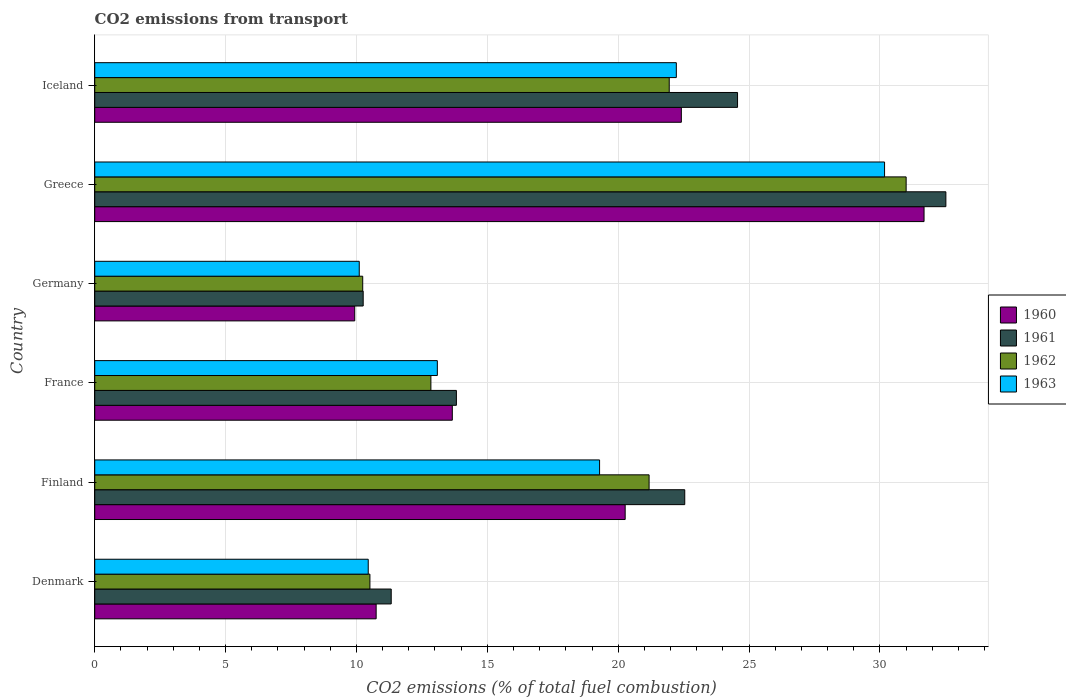How many groups of bars are there?
Your response must be concise. 6. Are the number of bars per tick equal to the number of legend labels?
Ensure brevity in your answer.  Yes. How many bars are there on the 3rd tick from the top?
Offer a very short reply. 4. How many bars are there on the 6th tick from the bottom?
Offer a terse response. 4. What is the label of the 4th group of bars from the top?
Your answer should be very brief. France. What is the total CO2 emitted in 1960 in Denmark?
Keep it short and to the point. 10.75. Across all countries, what is the maximum total CO2 emitted in 1963?
Your answer should be compact. 30.18. Across all countries, what is the minimum total CO2 emitted in 1961?
Your response must be concise. 10.26. In which country was the total CO2 emitted in 1960 minimum?
Your answer should be compact. Germany. What is the total total CO2 emitted in 1963 in the graph?
Provide a succinct answer. 105.34. What is the difference between the total CO2 emitted in 1961 in France and that in Greece?
Provide a short and direct response. -18.7. What is the difference between the total CO2 emitted in 1961 in Denmark and the total CO2 emitted in 1962 in Finland?
Provide a short and direct response. -9.85. What is the average total CO2 emitted in 1962 per country?
Your answer should be very brief. 17.96. What is the difference between the total CO2 emitted in 1961 and total CO2 emitted in 1960 in Germany?
Offer a very short reply. 0.32. What is the ratio of the total CO2 emitted in 1962 in France to that in Iceland?
Provide a short and direct response. 0.59. Is the difference between the total CO2 emitted in 1961 in Denmark and Iceland greater than the difference between the total CO2 emitted in 1960 in Denmark and Iceland?
Your answer should be very brief. No. What is the difference between the highest and the second highest total CO2 emitted in 1960?
Make the answer very short. 9.27. What is the difference between the highest and the lowest total CO2 emitted in 1961?
Offer a terse response. 22.26. In how many countries, is the total CO2 emitted in 1960 greater than the average total CO2 emitted in 1960 taken over all countries?
Your answer should be very brief. 3. Is the sum of the total CO2 emitted in 1963 in Denmark and Iceland greater than the maximum total CO2 emitted in 1961 across all countries?
Your response must be concise. Yes. Is it the case that in every country, the sum of the total CO2 emitted in 1961 and total CO2 emitted in 1960 is greater than the sum of total CO2 emitted in 1962 and total CO2 emitted in 1963?
Ensure brevity in your answer.  No. What does the 1st bar from the top in Denmark represents?
Keep it short and to the point. 1963. Is it the case that in every country, the sum of the total CO2 emitted in 1960 and total CO2 emitted in 1963 is greater than the total CO2 emitted in 1961?
Give a very brief answer. Yes. Are the values on the major ticks of X-axis written in scientific E-notation?
Give a very brief answer. No. Does the graph contain any zero values?
Offer a terse response. No. How are the legend labels stacked?
Make the answer very short. Vertical. What is the title of the graph?
Your response must be concise. CO2 emissions from transport. What is the label or title of the X-axis?
Your answer should be compact. CO2 emissions (% of total fuel combustion). What is the CO2 emissions (% of total fuel combustion) of 1960 in Denmark?
Keep it short and to the point. 10.75. What is the CO2 emissions (% of total fuel combustion) in 1961 in Denmark?
Offer a terse response. 11.33. What is the CO2 emissions (% of total fuel combustion) in 1962 in Denmark?
Make the answer very short. 10.51. What is the CO2 emissions (% of total fuel combustion) of 1963 in Denmark?
Your response must be concise. 10.45. What is the CO2 emissions (% of total fuel combustion) in 1960 in Finland?
Provide a succinct answer. 20.27. What is the CO2 emissions (% of total fuel combustion) of 1961 in Finland?
Your response must be concise. 22.54. What is the CO2 emissions (% of total fuel combustion) of 1962 in Finland?
Provide a short and direct response. 21.18. What is the CO2 emissions (% of total fuel combustion) in 1963 in Finland?
Ensure brevity in your answer.  19.29. What is the CO2 emissions (% of total fuel combustion) in 1960 in France?
Give a very brief answer. 13.66. What is the CO2 emissions (% of total fuel combustion) in 1961 in France?
Offer a very short reply. 13.82. What is the CO2 emissions (% of total fuel combustion) of 1962 in France?
Provide a short and direct response. 12.84. What is the CO2 emissions (% of total fuel combustion) in 1963 in France?
Ensure brevity in your answer.  13.09. What is the CO2 emissions (% of total fuel combustion) of 1960 in Germany?
Make the answer very short. 9.93. What is the CO2 emissions (% of total fuel combustion) of 1961 in Germany?
Your response must be concise. 10.26. What is the CO2 emissions (% of total fuel combustion) in 1962 in Germany?
Give a very brief answer. 10.24. What is the CO2 emissions (% of total fuel combustion) in 1963 in Germany?
Keep it short and to the point. 10.11. What is the CO2 emissions (% of total fuel combustion) of 1960 in Greece?
Your answer should be very brief. 31.69. What is the CO2 emissions (% of total fuel combustion) in 1961 in Greece?
Offer a terse response. 32.52. What is the CO2 emissions (% of total fuel combustion) of 1962 in Greece?
Provide a short and direct response. 31. What is the CO2 emissions (% of total fuel combustion) of 1963 in Greece?
Provide a short and direct response. 30.18. What is the CO2 emissions (% of total fuel combustion) of 1960 in Iceland?
Keep it short and to the point. 22.41. What is the CO2 emissions (% of total fuel combustion) in 1961 in Iceland?
Give a very brief answer. 24.56. What is the CO2 emissions (% of total fuel combustion) of 1962 in Iceland?
Offer a terse response. 21.95. What is the CO2 emissions (% of total fuel combustion) in 1963 in Iceland?
Offer a terse response. 22.22. Across all countries, what is the maximum CO2 emissions (% of total fuel combustion) in 1960?
Give a very brief answer. 31.69. Across all countries, what is the maximum CO2 emissions (% of total fuel combustion) of 1961?
Ensure brevity in your answer.  32.52. Across all countries, what is the maximum CO2 emissions (% of total fuel combustion) of 1962?
Keep it short and to the point. 31. Across all countries, what is the maximum CO2 emissions (% of total fuel combustion) in 1963?
Your answer should be compact. 30.18. Across all countries, what is the minimum CO2 emissions (% of total fuel combustion) in 1960?
Ensure brevity in your answer.  9.93. Across all countries, what is the minimum CO2 emissions (% of total fuel combustion) in 1961?
Ensure brevity in your answer.  10.26. Across all countries, what is the minimum CO2 emissions (% of total fuel combustion) of 1962?
Offer a terse response. 10.24. Across all countries, what is the minimum CO2 emissions (% of total fuel combustion) of 1963?
Your answer should be very brief. 10.11. What is the total CO2 emissions (% of total fuel combustion) in 1960 in the graph?
Your answer should be very brief. 108.72. What is the total CO2 emissions (% of total fuel combustion) in 1961 in the graph?
Your answer should be very brief. 115.03. What is the total CO2 emissions (% of total fuel combustion) of 1962 in the graph?
Your answer should be compact. 107.73. What is the total CO2 emissions (% of total fuel combustion) in 1963 in the graph?
Offer a terse response. 105.34. What is the difference between the CO2 emissions (% of total fuel combustion) of 1960 in Denmark and that in Finland?
Make the answer very short. -9.51. What is the difference between the CO2 emissions (% of total fuel combustion) of 1961 in Denmark and that in Finland?
Ensure brevity in your answer.  -11.22. What is the difference between the CO2 emissions (% of total fuel combustion) in 1962 in Denmark and that in Finland?
Ensure brevity in your answer.  -10.67. What is the difference between the CO2 emissions (% of total fuel combustion) in 1963 in Denmark and that in Finland?
Keep it short and to the point. -8.84. What is the difference between the CO2 emissions (% of total fuel combustion) in 1960 in Denmark and that in France?
Give a very brief answer. -2.91. What is the difference between the CO2 emissions (% of total fuel combustion) of 1961 in Denmark and that in France?
Ensure brevity in your answer.  -2.49. What is the difference between the CO2 emissions (% of total fuel combustion) of 1962 in Denmark and that in France?
Give a very brief answer. -2.33. What is the difference between the CO2 emissions (% of total fuel combustion) of 1963 in Denmark and that in France?
Offer a very short reply. -2.64. What is the difference between the CO2 emissions (% of total fuel combustion) in 1960 in Denmark and that in Germany?
Your answer should be very brief. 0.82. What is the difference between the CO2 emissions (% of total fuel combustion) of 1961 in Denmark and that in Germany?
Your answer should be very brief. 1.07. What is the difference between the CO2 emissions (% of total fuel combustion) of 1962 in Denmark and that in Germany?
Provide a short and direct response. 0.28. What is the difference between the CO2 emissions (% of total fuel combustion) of 1963 in Denmark and that in Germany?
Your answer should be very brief. 0.34. What is the difference between the CO2 emissions (% of total fuel combustion) in 1960 in Denmark and that in Greece?
Keep it short and to the point. -20.93. What is the difference between the CO2 emissions (% of total fuel combustion) in 1961 in Denmark and that in Greece?
Make the answer very short. -21.19. What is the difference between the CO2 emissions (% of total fuel combustion) of 1962 in Denmark and that in Greece?
Make the answer very short. -20.49. What is the difference between the CO2 emissions (% of total fuel combustion) in 1963 in Denmark and that in Greece?
Keep it short and to the point. -19.73. What is the difference between the CO2 emissions (% of total fuel combustion) of 1960 in Denmark and that in Iceland?
Make the answer very short. -11.66. What is the difference between the CO2 emissions (% of total fuel combustion) in 1961 in Denmark and that in Iceland?
Give a very brief answer. -13.23. What is the difference between the CO2 emissions (% of total fuel combustion) of 1962 in Denmark and that in Iceland?
Offer a very short reply. -11.44. What is the difference between the CO2 emissions (% of total fuel combustion) of 1963 in Denmark and that in Iceland?
Provide a succinct answer. -11.77. What is the difference between the CO2 emissions (% of total fuel combustion) in 1960 in Finland and that in France?
Offer a very short reply. 6.6. What is the difference between the CO2 emissions (% of total fuel combustion) in 1961 in Finland and that in France?
Offer a terse response. 8.73. What is the difference between the CO2 emissions (% of total fuel combustion) in 1962 in Finland and that in France?
Offer a terse response. 8.34. What is the difference between the CO2 emissions (% of total fuel combustion) in 1963 in Finland and that in France?
Your answer should be compact. 6.2. What is the difference between the CO2 emissions (% of total fuel combustion) in 1960 in Finland and that in Germany?
Provide a short and direct response. 10.33. What is the difference between the CO2 emissions (% of total fuel combustion) of 1961 in Finland and that in Germany?
Offer a terse response. 12.29. What is the difference between the CO2 emissions (% of total fuel combustion) in 1962 in Finland and that in Germany?
Your answer should be very brief. 10.94. What is the difference between the CO2 emissions (% of total fuel combustion) of 1963 in Finland and that in Germany?
Your answer should be compact. 9.18. What is the difference between the CO2 emissions (% of total fuel combustion) of 1960 in Finland and that in Greece?
Ensure brevity in your answer.  -11.42. What is the difference between the CO2 emissions (% of total fuel combustion) in 1961 in Finland and that in Greece?
Ensure brevity in your answer.  -9.98. What is the difference between the CO2 emissions (% of total fuel combustion) of 1962 in Finland and that in Greece?
Offer a very short reply. -9.82. What is the difference between the CO2 emissions (% of total fuel combustion) in 1963 in Finland and that in Greece?
Provide a short and direct response. -10.89. What is the difference between the CO2 emissions (% of total fuel combustion) in 1960 in Finland and that in Iceland?
Your answer should be very brief. -2.15. What is the difference between the CO2 emissions (% of total fuel combustion) in 1961 in Finland and that in Iceland?
Your answer should be compact. -2.02. What is the difference between the CO2 emissions (% of total fuel combustion) of 1962 in Finland and that in Iceland?
Make the answer very short. -0.77. What is the difference between the CO2 emissions (% of total fuel combustion) of 1963 in Finland and that in Iceland?
Your answer should be very brief. -2.93. What is the difference between the CO2 emissions (% of total fuel combustion) in 1960 in France and that in Germany?
Your answer should be very brief. 3.73. What is the difference between the CO2 emissions (% of total fuel combustion) of 1961 in France and that in Germany?
Provide a short and direct response. 3.56. What is the difference between the CO2 emissions (% of total fuel combustion) in 1962 in France and that in Germany?
Your answer should be compact. 2.6. What is the difference between the CO2 emissions (% of total fuel combustion) of 1963 in France and that in Germany?
Offer a very short reply. 2.98. What is the difference between the CO2 emissions (% of total fuel combustion) of 1960 in France and that in Greece?
Offer a terse response. -18.02. What is the difference between the CO2 emissions (% of total fuel combustion) in 1961 in France and that in Greece?
Provide a succinct answer. -18.7. What is the difference between the CO2 emissions (% of total fuel combustion) in 1962 in France and that in Greece?
Your answer should be very brief. -18.16. What is the difference between the CO2 emissions (% of total fuel combustion) of 1963 in France and that in Greece?
Your response must be concise. -17.09. What is the difference between the CO2 emissions (% of total fuel combustion) in 1960 in France and that in Iceland?
Your answer should be compact. -8.75. What is the difference between the CO2 emissions (% of total fuel combustion) in 1961 in France and that in Iceland?
Offer a terse response. -10.74. What is the difference between the CO2 emissions (% of total fuel combustion) of 1962 in France and that in Iceland?
Your response must be concise. -9.11. What is the difference between the CO2 emissions (% of total fuel combustion) of 1963 in France and that in Iceland?
Offer a terse response. -9.13. What is the difference between the CO2 emissions (% of total fuel combustion) in 1960 in Germany and that in Greece?
Provide a short and direct response. -21.75. What is the difference between the CO2 emissions (% of total fuel combustion) of 1961 in Germany and that in Greece?
Make the answer very short. -22.26. What is the difference between the CO2 emissions (% of total fuel combustion) of 1962 in Germany and that in Greece?
Provide a short and direct response. -20.76. What is the difference between the CO2 emissions (% of total fuel combustion) in 1963 in Germany and that in Greece?
Offer a very short reply. -20.07. What is the difference between the CO2 emissions (% of total fuel combustion) of 1960 in Germany and that in Iceland?
Keep it short and to the point. -12.48. What is the difference between the CO2 emissions (% of total fuel combustion) in 1961 in Germany and that in Iceland?
Keep it short and to the point. -14.3. What is the difference between the CO2 emissions (% of total fuel combustion) of 1962 in Germany and that in Iceland?
Your response must be concise. -11.71. What is the difference between the CO2 emissions (% of total fuel combustion) of 1963 in Germany and that in Iceland?
Keep it short and to the point. -12.12. What is the difference between the CO2 emissions (% of total fuel combustion) in 1960 in Greece and that in Iceland?
Your answer should be very brief. 9.27. What is the difference between the CO2 emissions (% of total fuel combustion) in 1961 in Greece and that in Iceland?
Your response must be concise. 7.96. What is the difference between the CO2 emissions (% of total fuel combustion) in 1962 in Greece and that in Iceland?
Provide a short and direct response. 9.05. What is the difference between the CO2 emissions (% of total fuel combustion) of 1963 in Greece and that in Iceland?
Your response must be concise. 7.96. What is the difference between the CO2 emissions (% of total fuel combustion) in 1960 in Denmark and the CO2 emissions (% of total fuel combustion) in 1961 in Finland?
Ensure brevity in your answer.  -11.79. What is the difference between the CO2 emissions (% of total fuel combustion) in 1960 in Denmark and the CO2 emissions (% of total fuel combustion) in 1962 in Finland?
Ensure brevity in your answer.  -10.43. What is the difference between the CO2 emissions (% of total fuel combustion) in 1960 in Denmark and the CO2 emissions (% of total fuel combustion) in 1963 in Finland?
Offer a terse response. -8.54. What is the difference between the CO2 emissions (% of total fuel combustion) of 1961 in Denmark and the CO2 emissions (% of total fuel combustion) of 1962 in Finland?
Your answer should be very brief. -9.85. What is the difference between the CO2 emissions (% of total fuel combustion) in 1961 in Denmark and the CO2 emissions (% of total fuel combustion) in 1963 in Finland?
Your answer should be very brief. -7.96. What is the difference between the CO2 emissions (% of total fuel combustion) of 1962 in Denmark and the CO2 emissions (% of total fuel combustion) of 1963 in Finland?
Keep it short and to the point. -8.78. What is the difference between the CO2 emissions (% of total fuel combustion) of 1960 in Denmark and the CO2 emissions (% of total fuel combustion) of 1961 in France?
Offer a terse response. -3.07. What is the difference between the CO2 emissions (% of total fuel combustion) in 1960 in Denmark and the CO2 emissions (% of total fuel combustion) in 1962 in France?
Provide a succinct answer. -2.09. What is the difference between the CO2 emissions (% of total fuel combustion) in 1960 in Denmark and the CO2 emissions (% of total fuel combustion) in 1963 in France?
Your answer should be very brief. -2.34. What is the difference between the CO2 emissions (% of total fuel combustion) in 1961 in Denmark and the CO2 emissions (% of total fuel combustion) in 1962 in France?
Your answer should be very brief. -1.52. What is the difference between the CO2 emissions (% of total fuel combustion) in 1961 in Denmark and the CO2 emissions (% of total fuel combustion) in 1963 in France?
Provide a succinct answer. -1.76. What is the difference between the CO2 emissions (% of total fuel combustion) of 1962 in Denmark and the CO2 emissions (% of total fuel combustion) of 1963 in France?
Your answer should be compact. -2.58. What is the difference between the CO2 emissions (% of total fuel combustion) in 1960 in Denmark and the CO2 emissions (% of total fuel combustion) in 1961 in Germany?
Offer a terse response. 0.5. What is the difference between the CO2 emissions (% of total fuel combustion) of 1960 in Denmark and the CO2 emissions (% of total fuel combustion) of 1962 in Germany?
Ensure brevity in your answer.  0.51. What is the difference between the CO2 emissions (% of total fuel combustion) in 1960 in Denmark and the CO2 emissions (% of total fuel combustion) in 1963 in Germany?
Your answer should be very brief. 0.65. What is the difference between the CO2 emissions (% of total fuel combustion) in 1961 in Denmark and the CO2 emissions (% of total fuel combustion) in 1962 in Germany?
Your answer should be very brief. 1.09. What is the difference between the CO2 emissions (% of total fuel combustion) of 1961 in Denmark and the CO2 emissions (% of total fuel combustion) of 1963 in Germany?
Your answer should be compact. 1.22. What is the difference between the CO2 emissions (% of total fuel combustion) in 1962 in Denmark and the CO2 emissions (% of total fuel combustion) in 1963 in Germany?
Provide a short and direct response. 0.41. What is the difference between the CO2 emissions (% of total fuel combustion) in 1960 in Denmark and the CO2 emissions (% of total fuel combustion) in 1961 in Greece?
Provide a short and direct response. -21.77. What is the difference between the CO2 emissions (% of total fuel combustion) in 1960 in Denmark and the CO2 emissions (% of total fuel combustion) in 1962 in Greece?
Keep it short and to the point. -20.25. What is the difference between the CO2 emissions (% of total fuel combustion) of 1960 in Denmark and the CO2 emissions (% of total fuel combustion) of 1963 in Greece?
Keep it short and to the point. -19.43. What is the difference between the CO2 emissions (% of total fuel combustion) of 1961 in Denmark and the CO2 emissions (% of total fuel combustion) of 1962 in Greece?
Make the answer very short. -19.67. What is the difference between the CO2 emissions (% of total fuel combustion) of 1961 in Denmark and the CO2 emissions (% of total fuel combustion) of 1963 in Greece?
Your answer should be very brief. -18.85. What is the difference between the CO2 emissions (% of total fuel combustion) in 1962 in Denmark and the CO2 emissions (% of total fuel combustion) in 1963 in Greece?
Make the answer very short. -19.66. What is the difference between the CO2 emissions (% of total fuel combustion) in 1960 in Denmark and the CO2 emissions (% of total fuel combustion) in 1961 in Iceland?
Your answer should be very brief. -13.81. What is the difference between the CO2 emissions (% of total fuel combustion) in 1960 in Denmark and the CO2 emissions (% of total fuel combustion) in 1962 in Iceland?
Keep it short and to the point. -11.2. What is the difference between the CO2 emissions (% of total fuel combustion) in 1960 in Denmark and the CO2 emissions (% of total fuel combustion) in 1963 in Iceland?
Ensure brevity in your answer.  -11.47. What is the difference between the CO2 emissions (% of total fuel combustion) in 1961 in Denmark and the CO2 emissions (% of total fuel combustion) in 1962 in Iceland?
Your response must be concise. -10.62. What is the difference between the CO2 emissions (% of total fuel combustion) in 1961 in Denmark and the CO2 emissions (% of total fuel combustion) in 1963 in Iceland?
Ensure brevity in your answer.  -10.89. What is the difference between the CO2 emissions (% of total fuel combustion) of 1962 in Denmark and the CO2 emissions (% of total fuel combustion) of 1963 in Iceland?
Provide a short and direct response. -11.71. What is the difference between the CO2 emissions (% of total fuel combustion) in 1960 in Finland and the CO2 emissions (% of total fuel combustion) in 1961 in France?
Your answer should be compact. 6.45. What is the difference between the CO2 emissions (% of total fuel combustion) in 1960 in Finland and the CO2 emissions (% of total fuel combustion) in 1962 in France?
Your response must be concise. 7.42. What is the difference between the CO2 emissions (% of total fuel combustion) in 1960 in Finland and the CO2 emissions (% of total fuel combustion) in 1963 in France?
Make the answer very short. 7.18. What is the difference between the CO2 emissions (% of total fuel combustion) in 1961 in Finland and the CO2 emissions (% of total fuel combustion) in 1962 in France?
Give a very brief answer. 9.7. What is the difference between the CO2 emissions (% of total fuel combustion) of 1961 in Finland and the CO2 emissions (% of total fuel combustion) of 1963 in France?
Your answer should be very brief. 9.45. What is the difference between the CO2 emissions (% of total fuel combustion) of 1962 in Finland and the CO2 emissions (% of total fuel combustion) of 1963 in France?
Your answer should be very brief. 8.09. What is the difference between the CO2 emissions (% of total fuel combustion) of 1960 in Finland and the CO2 emissions (% of total fuel combustion) of 1961 in Germany?
Provide a short and direct response. 10.01. What is the difference between the CO2 emissions (% of total fuel combustion) of 1960 in Finland and the CO2 emissions (% of total fuel combustion) of 1962 in Germany?
Make the answer very short. 10.03. What is the difference between the CO2 emissions (% of total fuel combustion) in 1960 in Finland and the CO2 emissions (% of total fuel combustion) in 1963 in Germany?
Give a very brief answer. 10.16. What is the difference between the CO2 emissions (% of total fuel combustion) in 1961 in Finland and the CO2 emissions (% of total fuel combustion) in 1962 in Germany?
Provide a succinct answer. 12.3. What is the difference between the CO2 emissions (% of total fuel combustion) of 1961 in Finland and the CO2 emissions (% of total fuel combustion) of 1963 in Germany?
Keep it short and to the point. 12.44. What is the difference between the CO2 emissions (% of total fuel combustion) of 1962 in Finland and the CO2 emissions (% of total fuel combustion) of 1963 in Germany?
Your answer should be compact. 11.07. What is the difference between the CO2 emissions (% of total fuel combustion) of 1960 in Finland and the CO2 emissions (% of total fuel combustion) of 1961 in Greece?
Give a very brief answer. -12.25. What is the difference between the CO2 emissions (% of total fuel combustion) in 1960 in Finland and the CO2 emissions (% of total fuel combustion) in 1962 in Greece?
Keep it short and to the point. -10.74. What is the difference between the CO2 emissions (% of total fuel combustion) of 1960 in Finland and the CO2 emissions (% of total fuel combustion) of 1963 in Greece?
Keep it short and to the point. -9.91. What is the difference between the CO2 emissions (% of total fuel combustion) in 1961 in Finland and the CO2 emissions (% of total fuel combustion) in 1962 in Greece?
Give a very brief answer. -8.46. What is the difference between the CO2 emissions (% of total fuel combustion) of 1961 in Finland and the CO2 emissions (% of total fuel combustion) of 1963 in Greece?
Provide a short and direct response. -7.63. What is the difference between the CO2 emissions (% of total fuel combustion) in 1962 in Finland and the CO2 emissions (% of total fuel combustion) in 1963 in Greece?
Your response must be concise. -9. What is the difference between the CO2 emissions (% of total fuel combustion) in 1960 in Finland and the CO2 emissions (% of total fuel combustion) in 1961 in Iceland?
Keep it short and to the point. -4.29. What is the difference between the CO2 emissions (% of total fuel combustion) of 1960 in Finland and the CO2 emissions (% of total fuel combustion) of 1962 in Iceland?
Offer a very short reply. -1.68. What is the difference between the CO2 emissions (% of total fuel combustion) in 1960 in Finland and the CO2 emissions (% of total fuel combustion) in 1963 in Iceland?
Keep it short and to the point. -1.95. What is the difference between the CO2 emissions (% of total fuel combustion) of 1961 in Finland and the CO2 emissions (% of total fuel combustion) of 1962 in Iceland?
Your answer should be very brief. 0.59. What is the difference between the CO2 emissions (% of total fuel combustion) in 1961 in Finland and the CO2 emissions (% of total fuel combustion) in 1963 in Iceland?
Make the answer very short. 0.32. What is the difference between the CO2 emissions (% of total fuel combustion) of 1962 in Finland and the CO2 emissions (% of total fuel combustion) of 1963 in Iceland?
Keep it short and to the point. -1.04. What is the difference between the CO2 emissions (% of total fuel combustion) in 1960 in France and the CO2 emissions (% of total fuel combustion) in 1961 in Germany?
Your answer should be very brief. 3.41. What is the difference between the CO2 emissions (% of total fuel combustion) of 1960 in France and the CO2 emissions (% of total fuel combustion) of 1962 in Germany?
Your answer should be compact. 3.42. What is the difference between the CO2 emissions (% of total fuel combustion) of 1960 in France and the CO2 emissions (% of total fuel combustion) of 1963 in Germany?
Your answer should be compact. 3.56. What is the difference between the CO2 emissions (% of total fuel combustion) in 1961 in France and the CO2 emissions (% of total fuel combustion) in 1962 in Germany?
Keep it short and to the point. 3.58. What is the difference between the CO2 emissions (% of total fuel combustion) of 1961 in France and the CO2 emissions (% of total fuel combustion) of 1963 in Germany?
Your answer should be very brief. 3.71. What is the difference between the CO2 emissions (% of total fuel combustion) of 1962 in France and the CO2 emissions (% of total fuel combustion) of 1963 in Germany?
Provide a succinct answer. 2.74. What is the difference between the CO2 emissions (% of total fuel combustion) in 1960 in France and the CO2 emissions (% of total fuel combustion) in 1961 in Greece?
Make the answer very short. -18.86. What is the difference between the CO2 emissions (% of total fuel combustion) of 1960 in France and the CO2 emissions (% of total fuel combustion) of 1962 in Greece?
Offer a very short reply. -17.34. What is the difference between the CO2 emissions (% of total fuel combustion) in 1960 in France and the CO2 emissions (% of total fuel combustion) in 1963 in Greece?
Make the answer very short. -16.52. What is the difference between the CO2 emissions (% of total fuel combustion) in 1961 in France and the CO2 emissions (% of total fuel combustion) in 1962 in Greece?
Provide a succinct answer. -17.18. What is the difference between the CO2 emissions (% of total fuel combustion) of 1961 in France and the CO2 emissions (% of total fuel combustion) of 1963 in Greece?
Your answer should be compact. -16.36. What is the difference between the CO2 emissions (% of total fuel combustion) of 1962 in France and the CO2 emissions (% of total fuel combustion) of 1963 in Greece?
Keep it short and to the point. -17.33. What is the difference between the CO2 emissions (% of total fuel combustion) in 1960 in France and the CO2 emissions (% of total fuel combustion) in 1961 in Iceland?
Make the answer very short. -10.9. What is the difference between the CO2 emissions (% of total fuel combustion) in 1960 in France and the CO2 emissions (% of total fuel combustion) in 1962 in Iceland?
Your answer should be compact. -8.29. What is the difference between the CO2 emissions (% of total fuel combustion) in 1960 in France and the CO2 emissions (% of total fuel combustion) in 1963 in Iceland?
Your answer should be compact. -8.56. What is the difference between the CO2 emissions (% of total fuel combustion) in 1961 in France and the CO2 emissions (% of total fuel combustion) in 1962 in Iceland?
Offer a terse response. -8.13. What is the difference between the CO2 emissions (% of total fuel combustion) of 1961 in France and the CO2 emissions (% of total fuel combustion) of 1963 in Iceland?
Your response must be concise. -8.4. What is the difference between the CO2 emissions (% of total fuel combustion) in 1962 in France and the CO2 emissions (% of total fuel combustion) in 1963 in Iceland?
Your response must be concise. -9.38. What is the difference between the CO2 emissions (% of total fuel combustion) in 1960 in Germany and the CO2 emissions (% of total fuel combustion) in 1961 in Greece?
Offer a very short reply. -22.59. What is the difference between the CO2 emissions (% of total fuel combustion) in 1960 in Germany and the CO2 emissions (% of total fuel combustion) in 1962 in Greece?
Offer a very short reply. -21.07. What is the difference between the CO2 emissions (% of total fuel combustion) in 1960 in Germany and the CO2 emissions (% of total fuel combustion) in 1963 in Greece?
Offer a very short reply. -20.24. What is the difference between the CO2 emissions (% of total fuel combustion) in 1961 in Germany and the CO2 emissions (% of total fuel combustion) in 1962 in Greece?
Your answer should be very brief. -20.75. What is the difference between the CO2 emissions (% of total fuel combustion) of 1961 in Germany and the CO2 emissions (% of total fuel combustion) of 1963 in Greece?
Provide a succinct answer. -19.92. What is the difference between the CO2 emissions (% of total fuel combustion) of 1962 in Germany and the CO2 emissions (% of total fuel combustion) of 1963 in Greece?
Provide a succinct answer. -19.94. What is the difference between the CO2 emissions (% of total fuel combustion) of 1960 in Germany and the CO2 emissions (% of total fuel combustion) of 1961 in Iceland?
Provide a succinct answer. -14.63. What is the difference between the CO2 emissions (% of total fuel combustion) of 1960 in Germany and the CO2 emissions (% of total fuel combustion) of 1962 in Iceland?
Give a very brief answer. -12.02. What is the difference between the CO2 emissions (% of total fuel combustion) of 1960 in Germany and the CO2 emissions (% of total fuel combustion) of 1963 in Iceland?
Your answer should be very brief. -12.29. What is the difference between the CO2 emissions (% of total fuel combustion) of 1961 in Germany and the CO2 emissions (% of total fuel combustion) of 1962 in Iceland?
Ensure brevity in your answer.  -11.69. What is the difference between the CO2 emissions (% of total fuel combustion) in 1961 in Germany and the CO2 emissions (% of total fuel combustion) in 1963 in Iceland?
Offer a very short reply. -11.96. What is the difference between the CO2 emissions (% of total fuel combustion) of 1962 in Germany and the CO2 emissions (% of total fuel combustion) of 1963 in Iceland?
Your answer should be compact. -11.98. What is the difference between the CO2 emissions (% of total fuel combustion) of 1960 in Greece and the CO2 emissions (% of total fuel combustion) of 1961 in Iceland?
Provide a succinct answer. 7.13. What is the difference between the CO2 emissions (% of total fuel combustion) in 1960 in Greece and the CO2 emissions (% of total fuel combustion) in 1962 in Iceland?
Offer a terse response. 9.74. What is the difference between the CO2 emissions (% of total fuel combustion) of 1960 in Greece and the CO2 emissions (% of total fuel combustion) of 1963 in Iceland?
Provide a succinct answer. 9.46. What is the difference between the CO2 emissions (% of total fuel combustion) in 1961 in Greece and the CO2 emissions (% of total fuel combustion) in 1962 in Iceland?
Make the answer very short. 10.57. What is the difference between the CO2 emissions (% of total fuel combustion) of 1961 in Greece and the CO2 emissions (% of total fuel combustion) of 1963 in Iceland?
Give a very brief answer. 10.3. What is the difference between the CO2 emissions (% of total fuel combustion) in 1962 in Greece and the CO2 emissions (% of total fuel combustion) in 1963 in Iceland?
Give a very brief answer. 8.78. What is the average CO2 emissions (% of total fuel combustion) of 1960 per country?
Provide a succinct answer. 18.12. What is the average CO2 emissions (% of total fuel combustion) of 1961 per country?
Give a very brief answer. 19.17. What is the average CO2 emissions (% of total fuel combustion) in 1962 per country?
Your answer should be very brief. 17.96. What is the average CO2 emissions (% of total fuel combustion) in 1963 per country?
Your answer should be compact. 17.56. What is the difference between the CO2 emissions (% of total fuel combustion) of 1960 and CO2 emissions (% of total fuel combustion) of 1961 in Denmark?
Keep it short and to the point. -0.58. What is the difference between the CO2 emissions (% of total fuel combustion) in 1960 and CO2 emissions (% of total fuel combustion) in 1962 in Denmark?
Provide a succinct answer. 0.24. What is the difference between the CO2 emissions (% of total fuel combustion) in 1960 and CO2 emissions (% of total fuel combustion) in 1963 in Denmark?
Ensure brevity in your answer.  0.3. What is the difference between the CO2 emissions (% of total fuel combustion) in 1961 and CO2 emissions (% of total fuel combustion) in 1962 in Denmark?
Provide a short and direct response. 0.81. What is the difference between the CO2 emissions (% of total fuel combustion) of 1961 and CO2 emissions (% of total fuel combustion) of 1963 in Denmark?
Give a very brief answer. 0.88. What is the difference between the CO2 emissions (% of total fuel combustion) in 1962 and CO2 emissions (% of total fuel combustion) in 1963 in Denmark?
Keep it short and to the point. 0.06. What is the difference between the CO2 emissions (% of total fuel combustion) in 1960 and CO2 emissions (% of total fuel combustion) in 1961 in Finland?
Offer a very short reply. -2.28. What is the difference between the CO2 emissions (% of total fuel combustion) in 1960 and CO2 emissions (% of total fuel combustion) in 1962 in Finland?
Offer a very short reply. -0.91. What is the difference between the CO2 emissions (% of total fuel combustion) in 1960 and CO2 emissions (% of total fuel combustion) in 1963 in Finland?
Your response must be concise. 0.98. What is the difference between the CO2 emissions (% of total fuel combustion) in 1961 and CO2 emissions (% of total fuel combustion) in 1962 in Finland?
Your answer should be compact. 1.36. What is the difference between the CO2 emissions (% of total fuel combustion) of 1961 and CO2 emissions (% of total fuel combustion) of 1963 in Finland?
Your response must be concise. 3.25. What is the difference between the CO2 emissions (% of total fuel combustion) of 1962 and CO2 emissions (% of total fuel combustion) of 1963 in Finland?
Ensure brevity in your answer.  1.89. What is the difference between the CO2 emissions (% of total fuel combustion) in 1960 and CO2 emissions (% of total fuel combustion) in 1961 in France?
Your answer should be very brief. -0.16. What is the difference between the CO2 emissions (% of total fuel combustion) in 1960 and CO2 emissions (% of total fuel combustion) in 1962 in France?
Provide a short and direct response. 0.82. What is the difference between the CO2 emissions (% of total fuel combustion) in 1960 and CO2 emissions (% of total fuel combustion) in 1963 in France?
Your answer should be compact. 0.57. What is the difference between the CO2 emissions (% of total fuel combustion) of 1961 and CO2 emissions (% of total fuel combustion) of 1962 in France?
Your answer should be compact. 0.97. What is the difference between the CO2 emissions (% of total fuel combustion) in 1961 and CO2 emissions (% of total fuel combustion) in 1963 in France?
Your response must be concise. 0.73. What is the difference between the CO2 emissions (% of total fuel combustion) of 1962 and CO2 emissions (% of total fuel combustion) of 1963 in France?
Ensure brevity in your answer.  -0.25. What is the difference between the CO2 emissions (% of total fuel combustion) in 1960 and CO2 emissions (% of total fuel combustion) in 1961 in Germany?
Your answer should be very brief. -0.32. What is the difference between the CO2 emissions (% of total fuel combustion) in 1960 and CO2 emissions (% of total fuel combustion) in 1962 in Germany?
Keep it short and to the point. -0.3. What is the difference between the CO2 emissions (% of total fuel combustion) of 1960 and CO2 emissions (% of total fuel combustion) of 1963 in Germany?
Your answer should be compact. -0.17. What is the difference between the CO2 emissions (% of total fuel combustion) of 1961 and CO2 emissions (% of total fuel combustion) of 1962 in Germany?
Keep it short and to the point. 0.02. What is the difference between the CO2 emissions (% of total fuel combustion) in 1961 and CO2 emissions (% of total fuel combustion) in 1963 in Germany?
Offer a terse response. 0.15. What is the difference between the CO2 emissions (% of total fuel combustion) of 1962 and CO2 emissions (% of total fuel combustion) of 1963 in Germany?
Keep it short and to the point. 0.13. What is the difference between the CO2 emissions (% of total fuel combustion) in 1960 and CO2 emissions (% of total fuel combustion) in 1961 in Greece?
Offer a terse response. -0.83. What is the difference between the CO2 emissions (% of total fuel combustion) in 1960 and CO2 emissions (% of total fuel combustion) in 1962 in Greece?
Ensure brevity in your answer.  0.68. What is the difference between the CO2 emissions (% of total fuel combustion) in 1960 and CO2 emissions (% of total fuel combustion) in 1963 in Greece?
Provide a succinct answer. 1.51. What is the difference between the CO2 emissions (% of total fuel combustion) in 1961 and CO2 emissions (% of total fuel combustion) in 1962 in Greece?
Your response must be concise. 1.52. What is the difference between the CO2 emissions (% of total fuel combustion) of 1961 and CO2 emissions (% of total fuel combustion) of 1963 in Greece?
Your answer should be very brief. 2.34. What is the difference between the CO2 emissions (% of total fuel combustion) of 1962 and CO2 emissions (% of total fuel combustion) of 1963 in Greece?
Your answer should be very brief. 0.82. What is the difference between the CO2 emissions (% of total fuel combustion) of 1960 and CO2 emissions (% of total fuel combustion) of 1961 in Iceland?
Offer a very short reply. -2.15. What is the difference between the CO2 emissions (% of total fuel combustion) of 1960 and CO2 emissions (% of total fuel combustion) of 1962 in Iceland?
Provide a short and direct response. 0.46. What is the difference between the CO2 emissions (% of total fuel combustion) of 1960 and CO2 emissions (% of total fuel combustion) of 1963 in Iceland?
Your answer should be very brief. 0.19. What is the difference between the CO2 emissions (% of total fuel combustion) of 1961 and CO2 emissions (% of total fuel combustion) of 1962 in Iceland?
Your answer should be very brief. 2.61. What is the difference between the CO2 emissions (% of total fuel combustion) in 1961 and CO2 emissions (% of total fuel combustion) in 1963 in Iceland?
Keep it short and to the point. 2.34. What is the difference between the CO2 emissions (% of total fuel combustion) of 1962 and CO2 emissions (% of total fuel combustion) of 1963 in Iceland?
Your answer should be very brief. -0.27. What is the ratio of the CO2 emissions (% of total fuel combustion) of 1960 in Denmark to that in Finland?
Keep it short and to the point. 0.53. What is the ratio of the CO2 emissions (% of total fuel combustion) of 1961 in Denmark to that in Finland?
Offer a terse response. 0.5. What is the ratio of the CO2 emissions (% of total fuel combustion) in 1962 in Denmark to that in Finland?
Offer a very short reply. 0.5. What is the ratio of the CO2 emissions (% of total fuel combustion) of 1963 in Denmark to that in Finland?
Provide a succinct answer. 0.54. What is the ratio of the CO2 emissions (% of total fuel combustion) in 1960 in Denmark to that in France?
Your answer should be compact. 0.79. What is the ratio of the CO2 emissions (% of total fuel combustion) of 1961 in Denmark to that in France?
Offer a very short reply. 0.82. What is the ratio of the CO2 emissions (% of total fuel combustion) in 1962 in Denmark to that in France?
Your answer should be very brief. 0.82. What is the ratio of the CO2 emissions (% of total fuel combustion) in 1963 in Denmark to that in France?
Offer a terse response. 0.8. What is the ratio of the CO2 emissions (% of total fuel combustion) in 1960 in Denmark to that in Germany?
Ensure brevity in your answer.  1.08. What is the ratio of the CO2 emissions (% of total fuel combustion) in 1961 in Denmark to that in Germany?
Your answer should be compact. 1.1. What is the ratio of the CO2 emissions (% of total fuel combustion) in 1962 in Denmark to that in Germany?
Your response must be concise. 1.03. What is the ratio of the CO2 emissions (% of total fuel combustion) of 1963 in Denmark to that in Germany?
Your answer should be very brief. 1.03. What is the ratio of the CO2 emissions (% of total fuel combustion) in 1960 in Denmark to that in Greece?
Ensure brevity in your answer.  0.34. What is the ratio of the CO2 emissions (% of total fuel combustion) of 1961 in Denmark to that in Greece?
Ensure brevity in your answer.  0.35. What is the ratio of the CO2 emissions (% of total fuel combustion) of 1962 in Denmark to that in Greece?
Your response must be concise. 0.34. What is the ratio of the CO2 emissions (% of total fuel combustion) of 1963 in Denmark to that in Greece?
Give a very brief answer. 0.35. What is the ratio of the CO2 emissions (% of total fuel combustion) of 1960 in Denmark to that in Iceland?
Your answer should be very brief. 0.48. What is the ratio of the CO2 emissions (% of total fuel combustion) of 1961 in Denmark to that in Iceland?
Your answer should be compact. 0.46. What is the ratio of the CO2 emissions (% of total fuel combustion) in 1962 in Denmark to that in Iceland?
Provide a short and direct response. 0.48. What is the ratio of the CO2 emissions (% of total fuel combustion) of 1963 in Denmark to that in Iceland?
Provide a short and direct response. 0.47. What is the ratio of the CO2 emissions (% of total fuel combustion) of 1960 in Finland to that in France?
Offer a very short reply. 1.48. What is the ratio of the CO2 emissions (% of total fuel combustion) in 1961 in Finland to that in France?
Make the answer very short. 1.63. What is the ratio of the CO2 emissions (% of total fuel combustion) in 1962 in Finland to that in France?
Your answer should be very brief. 1.65. What is the ratio of the CO2 emissions (% of total fuel combustion) in 1963 in Finland to that in France?
Your answer should be very brief. 1.47. What is the ratio of the CO2 emissions (% of total fuel combustion) of 1960 in Finland to that in Germany?
Provide a succinct answer. 2.04. What is the ratio of the CO2 emissions (% of total fuel combustion) of 1961 in Finland to that in Germany?
Give a very brief answer. 2.2. What is the ratio of the CO2 emissions (% of total fuel combustion) of 1962 in Finland to that in Germany?
Your answer should be very brief. 2.07. What is the ratio of the CO2 emissions (% of total fuel combustion) in 1963 in Finland to that in Germany?
Your response must be concise. 1.91. What is the ratio of the CO2 emissions (% of total fuel combustion) in 1960 in Finland to that in Greece?
Make the answer very short. 0.64. What is the ratio of the CO2 emissions (% of total fuel combustion) of 1961 in Finland to that in Greece?
Ensure brevity in your answer.  0.69. What is the ratio of the CO2 emissions (% of total fuel combustion) of 1962 in Finland to that in Greece?
Offer a very short reply. 0.68. What is the ratio of the CO2 emissions (% of total fuel combustion) in 1963 in Finland to that in Greece?
Give a very brief answer. 0.64. What is the ratio of the CO2 emissions (% of total fuel combustion) of 1960 in Finland to that in Iceland?
Keep it short and to the point. 0.9. What is the ratio of the CO2 emissions (% of total fuel combustion) in 1961 in Finland to that in Iceland?
Your answer should be compact. 0.92. What is the ratio of the CO2 emissions (% of total fuel combustion) of 1962 in Finland to that in Iceland?
Give a very brief answer. 0.96. What is the ratio of the CO2 emissions (% of total fuel combustion) of 1963 in Finland to that in Iceland?
Provide a succinct answer. 0.87. What is the ratio of the CO2 emissions (% of total fuel combustion) of 1960 in France to that in Germany?
Give a very brief answer. 1.38. What is the ratio of the CO2 emissions (% of total fuel combustion) in 1961 in France to that in Germany?
Keep it short and to the point. 1.35. What is the ratio of the CO2 emissions (% of total fuel combustion) of 1962 in France to that in Germany?
Your answer should be very brief. 1.25. What is the ratio of the CO2 emissions (% of total fuel combustion) in 1963 in France to that in Germany?
Ensure brevity in your answer.  1.3. What is the ratio of the CO2 emissions (% of total fuel combustion) in 1960 in France to that in Greece?
Offer a very short reply. 0.43. What is the ratio of the CO2 emissions (% of total fuel combustion) of 1961 in France to that in Greece?
Ensure brevity in your answer.  0.42. What is the ratio of the CO2 emissions (% of total fuel combustion) of 1962 in France to that in Greece?
Provide a short and direct response. 0.41. What is the ratio of the CO2 emissions (% of total fuel combustion) in 1963 in France to that in Greece?
Your response must be concise. 0.43. What is the ratio of the CO2 emissions (% of total fuel combustion) of 1960 in France to that in Iceland?
Make the answer very short. 0.61. What is the ratio of the CO2 emissions (% of total fuel combustion) in 1961 in France to that in Iceland?
Ensure brevity in your answer.  0.56. What is the ratio of the CO2 emissions (% of total fuel combustion) in 1962 in France to that in Iceland?
Keep it short and to the point. 0.59. What is the ratio of the CO2 emissions (% of total fuel combustion) in 1963 in France to that in Iceland?
Your answer should be very brief. 0.59. What is the ratio of the CO2 emissions (% of total fuel combustion) in 1960 in Germany to that in Greece?
Your answer should be compact. 0.31. What is the ratio of the CO2 emissions (% of total fuel combustion) of 1961 in Germany to that in Greece?
Your response must be concise. 0.32. What is the ratio of the CO2 emissions (% of total fuel combustion) of 1962 in Germany to that in Greece?
Offer a terse response. 0.33. What is the ratio of the CO2 emissions (% of total fuel combustion) of 1963 in Germany to that in Greece?
Keep it short and to the point. 0.33. What is the ratio of the CO2 emissions (% of total fuel combustion) of 1960 in Germany to that in Iceland?
Offer a terse response. 0.44. What is the ratio of the CO2 emissions (% of total fuel combustion) of 1961 in Germany to that in Iceland?
Provide a succinct answer. 0.42. What is the ratio of the CO2 emissions (% of total fuel combustion) of 1962 in Germany to that in Iceland?
Offer a very short reply. 0.47. What is the ratio of the CO2 emissions (% of total fuel combustion) of 1963 in Germany to that in Iceland?
Make the answer very short. 0.45. What is the ratio of the CO2 emissions (% of total fuel combustion) in 1960 in Greece to that in Iceland?
Provide a short and direct response. 1.41. What is the ratio of the CO2 emissions (% of total fuel combustion) of 1961 in Greece to that in Iceland?
Offer a terse response. 1.32. What is the ratio of the CO2 emissions (% of total fuel combustion) in 1962 in Greece to that in Iceland?
Ensure brevity in your answer.  1.41. What is the ratio of the CO2 emissions (% of total fuel combustion) of 1963 in Greece to that in Iceland?
Your answer should be compact. 1.36. What is the difference between the highest and the second highest CO2 emissions (% of total fuel combustion) in 1960?
Provide a short and direct response. 9.27. What is the difference between the highest and the second highest CO2 emissions (% of total fuel combustion) of 1961?
Provide a short and direct response. 7.96. What is the difference between the highest and the second highest CO2 emissions (% of total fuel combustion) in 1962?
Your answer should be compact. 9.05. What is the difference between the highest and the second highest CO2 emissions (% of total fuel combustion) of 1963?
Ensure brevity in your answer.  7.96. What is the difference between the highest and the lowest CO2 emissions (% of total fuel combustion) of 1960?
Your response must be concise. 21.75. What is the difference between the highest and the lowest CO2 emissions (% of total fuel combustion) of 1961?
Your answer should be very brief. 22.26. What is the difference between the highest and the lowest CO2 emissions (% of total fuel combustion) of 1962?
Your response must be concise. 20.76. What is the difference between the highest and the lowest CO2 emissions (% of total fuel combustion) in 1963?
Ensure brevity in your answer.  20.07. 